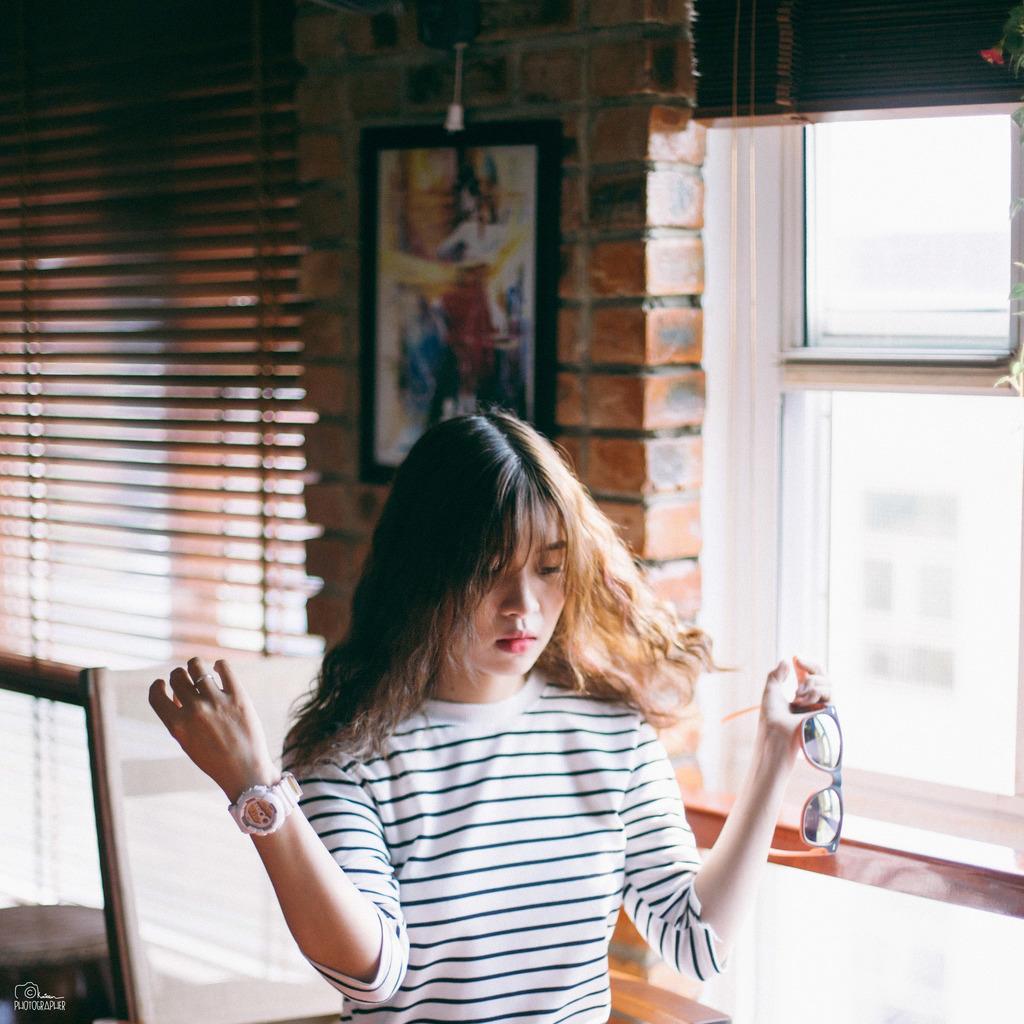Please provide a concise description of this image. In this image we can see a woman wearing white T-shirt and wrist watch is holding glasses in her hands and sitting on the chair. The background of the image is slightly blurred, where we can see a photo frame on the brick wall, we can see window blinds and the glass windows. Here we can see a watermark on the bottom left side of the image. 